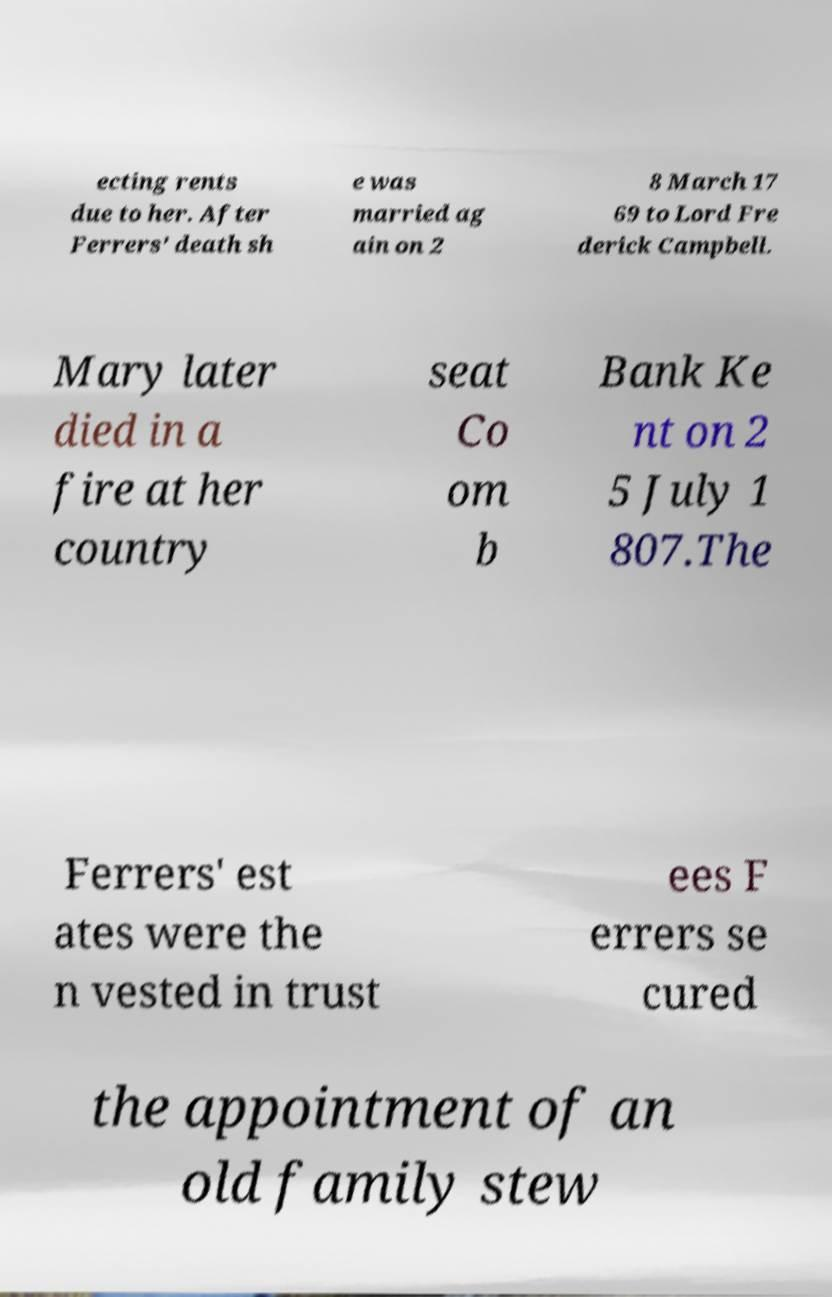I need the written content from this picture converted into text. Can you do that? ecting rents due to her. After Ferrers' death sh e was married ag ain on 2 8 March 17 69 to Lord Fre derick Campbell. Mary later died in a fire at her country seat Co om b Bank Ke nt on 2 5 July 1 807.The Ferrers' est ates were the n vested in trust ees F errers se cured the appointment of an old family stew 